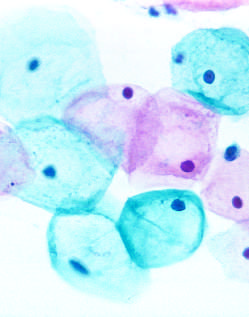what are exfoliated?
Answer the question using a single word or phrase. The cells 